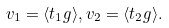<formula> <loc_0><loc_0><loc_500><loc_500>v _ { 1 } = \langle t _ { 1 } g \rangle , v _ { 2 } = \langle t _ { 2 } g \rangle .</formula> 